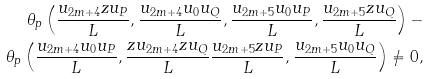<formula> <loc_0><loc_0><loc_500><loc_500>\theta _ { p } \left ( \frac { u _ { 2 m + 4 } z u _ { P } } { L } , \frac { u _ { 2 m + 4 } u _ { 0 } u _ { Q } } { L } , \frac { u _ { 2 m + 5 } u _ { 0 } u _ { P } } { L } , \frac { u _ { 2 m + 5 } z u _ { Q } } { L } \right ) - \\ \theta _ { p } \left ( \frac { u _ { 2 m + 4 } u _ { 0 } u _ { P } } { L } , \frac { z u _ { 2 m + 4 } z u _ { Q } } { L } \frac { u _ { 2 m + 5 } z u _ { P } } { L } , \frac { u _ { 2 m + 5 } u _ { 0 } u _ { Q } } { L } \right ) \neq 0 ,</formula> 